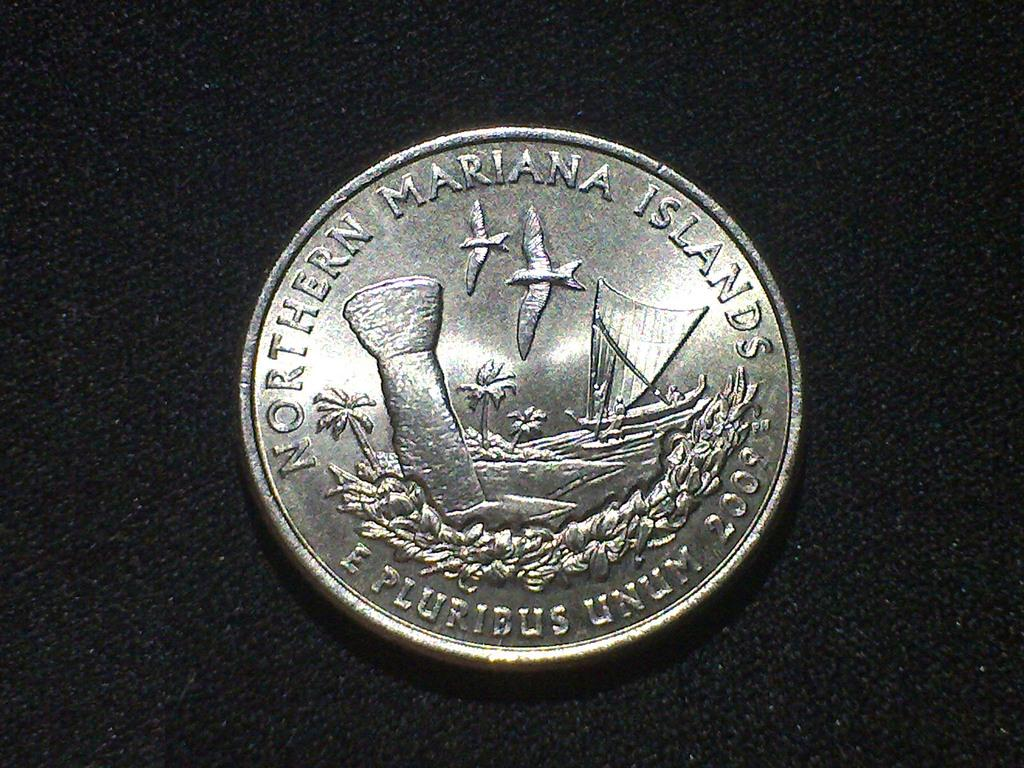<image>
Render a clear and concise summary of the photo. A Northern Marianas Islands coin has birds and palm trees on it. 